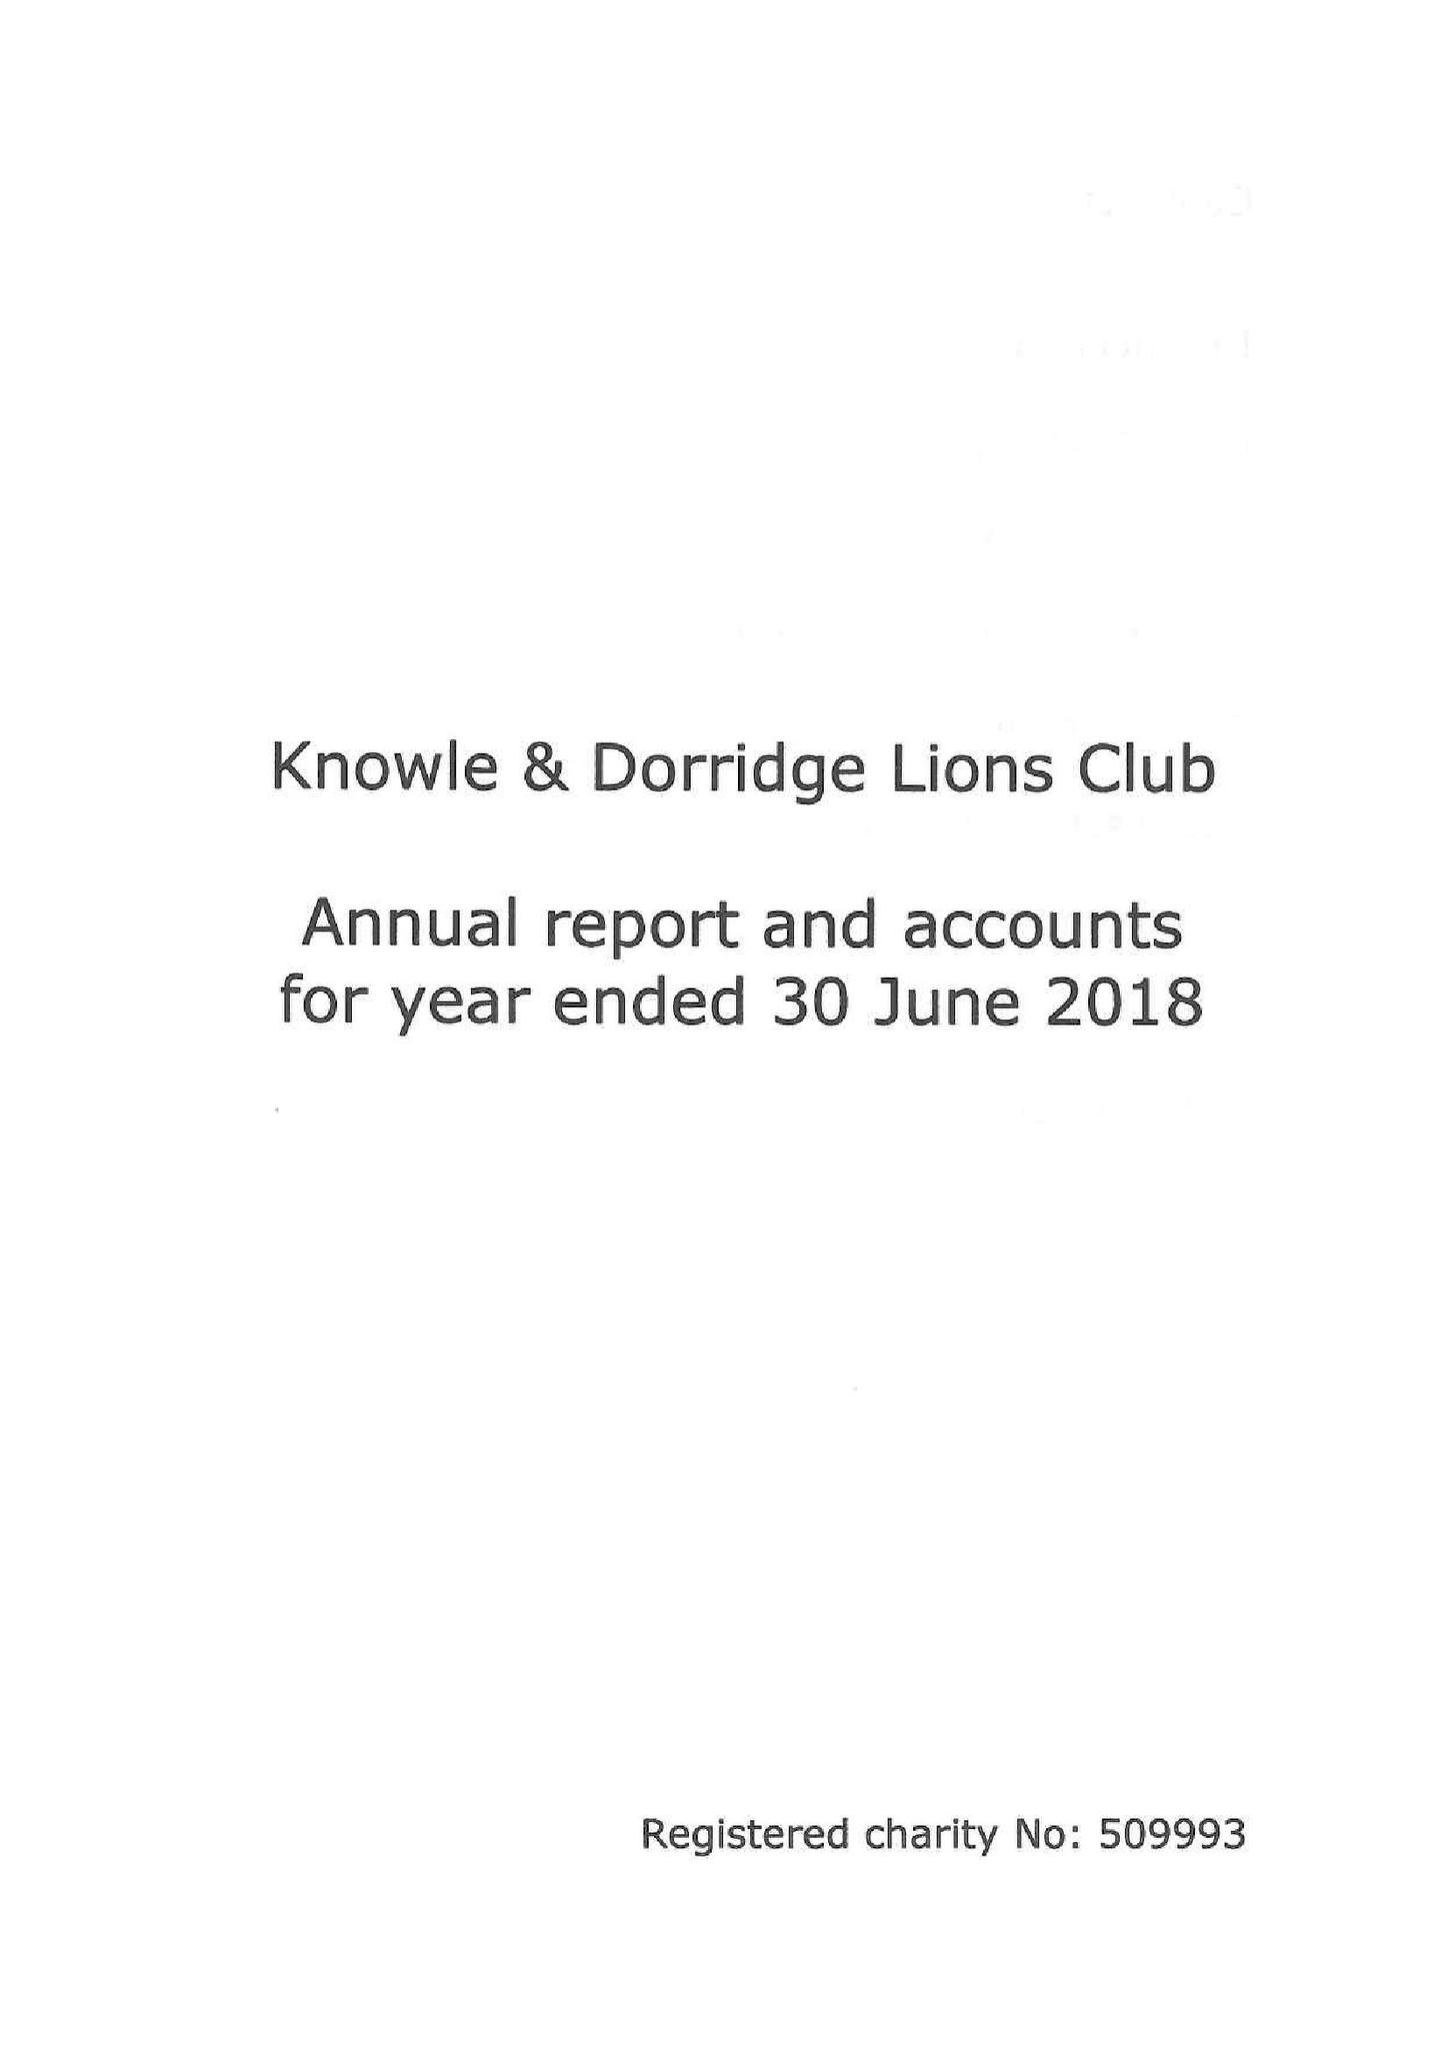What is the value for the income_annually_in_british_pounds?
Answer the question using a single word or phrase. 62027.42 